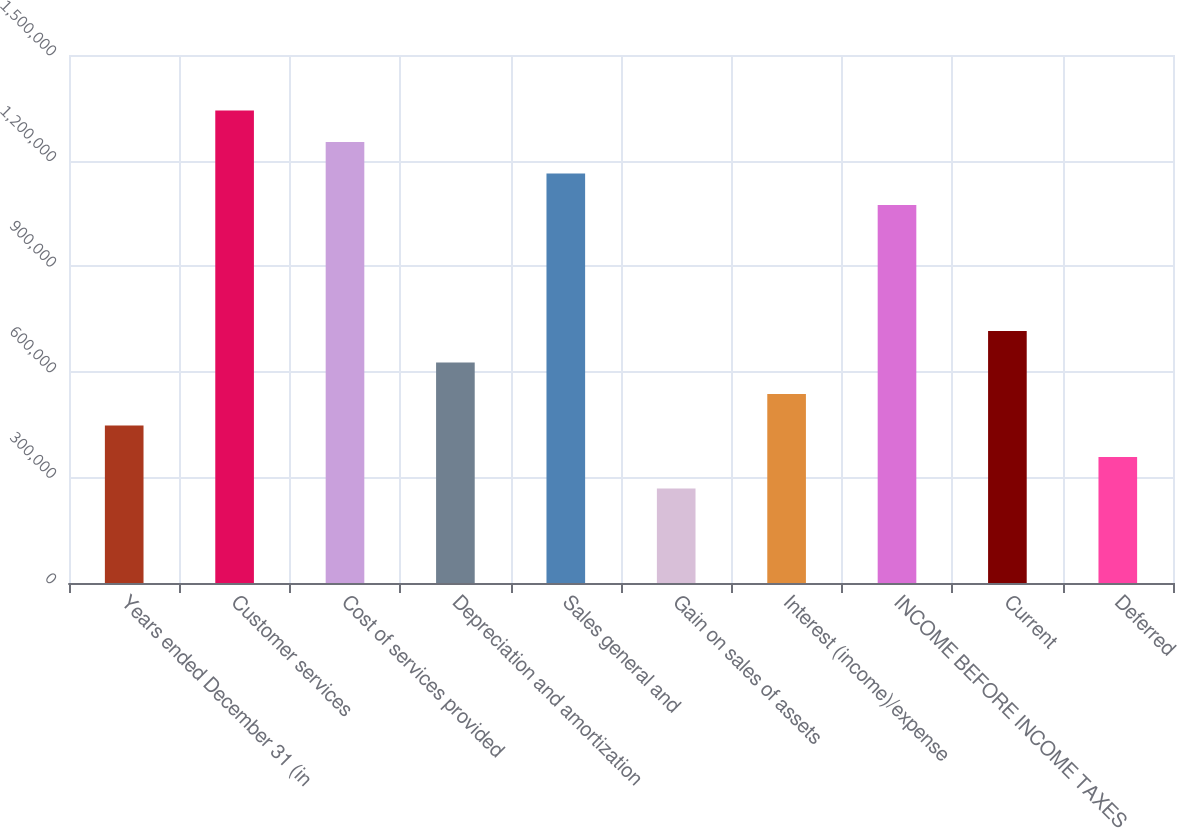Convert chart. <chart><loc_0><loc_0><loc_500><loc_500><bar_chart><fcel>Years ended December 31 (in<fcel>Customer services<fcel>Cost of services provided<fcel>Depreciation and amortization<fcel>Sales general and<fcel>Gain on sales of assets<fcel>Interest (income)/expense<fcel>INCOME BEFORE INCOME TAXES<fcel>Current<fcel>Deferred<nl><fcel>447460<fcel>1.34238e+06<fcel>1.25289e+06<fcel>626444<fcel>1.1634e+06<fcel>268476<fcel>536952<fcel>1.0739e+06<fcel>715936<fcel>357968<nl></chart> 